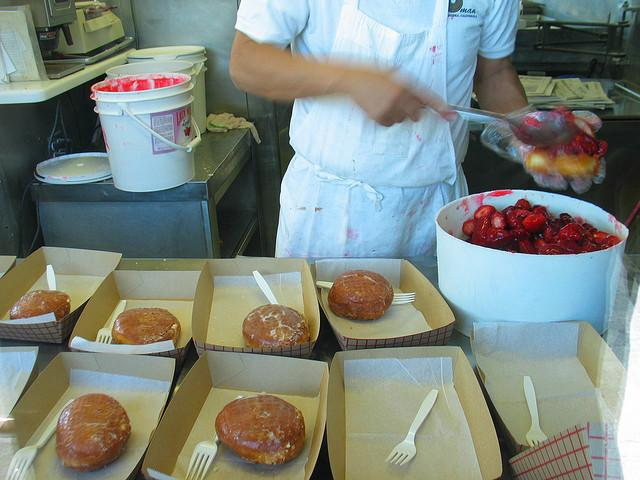What type of filling is in the donuts?

Choices:
A) icing
B) custard
C) chocolate
D) fruit fruit 